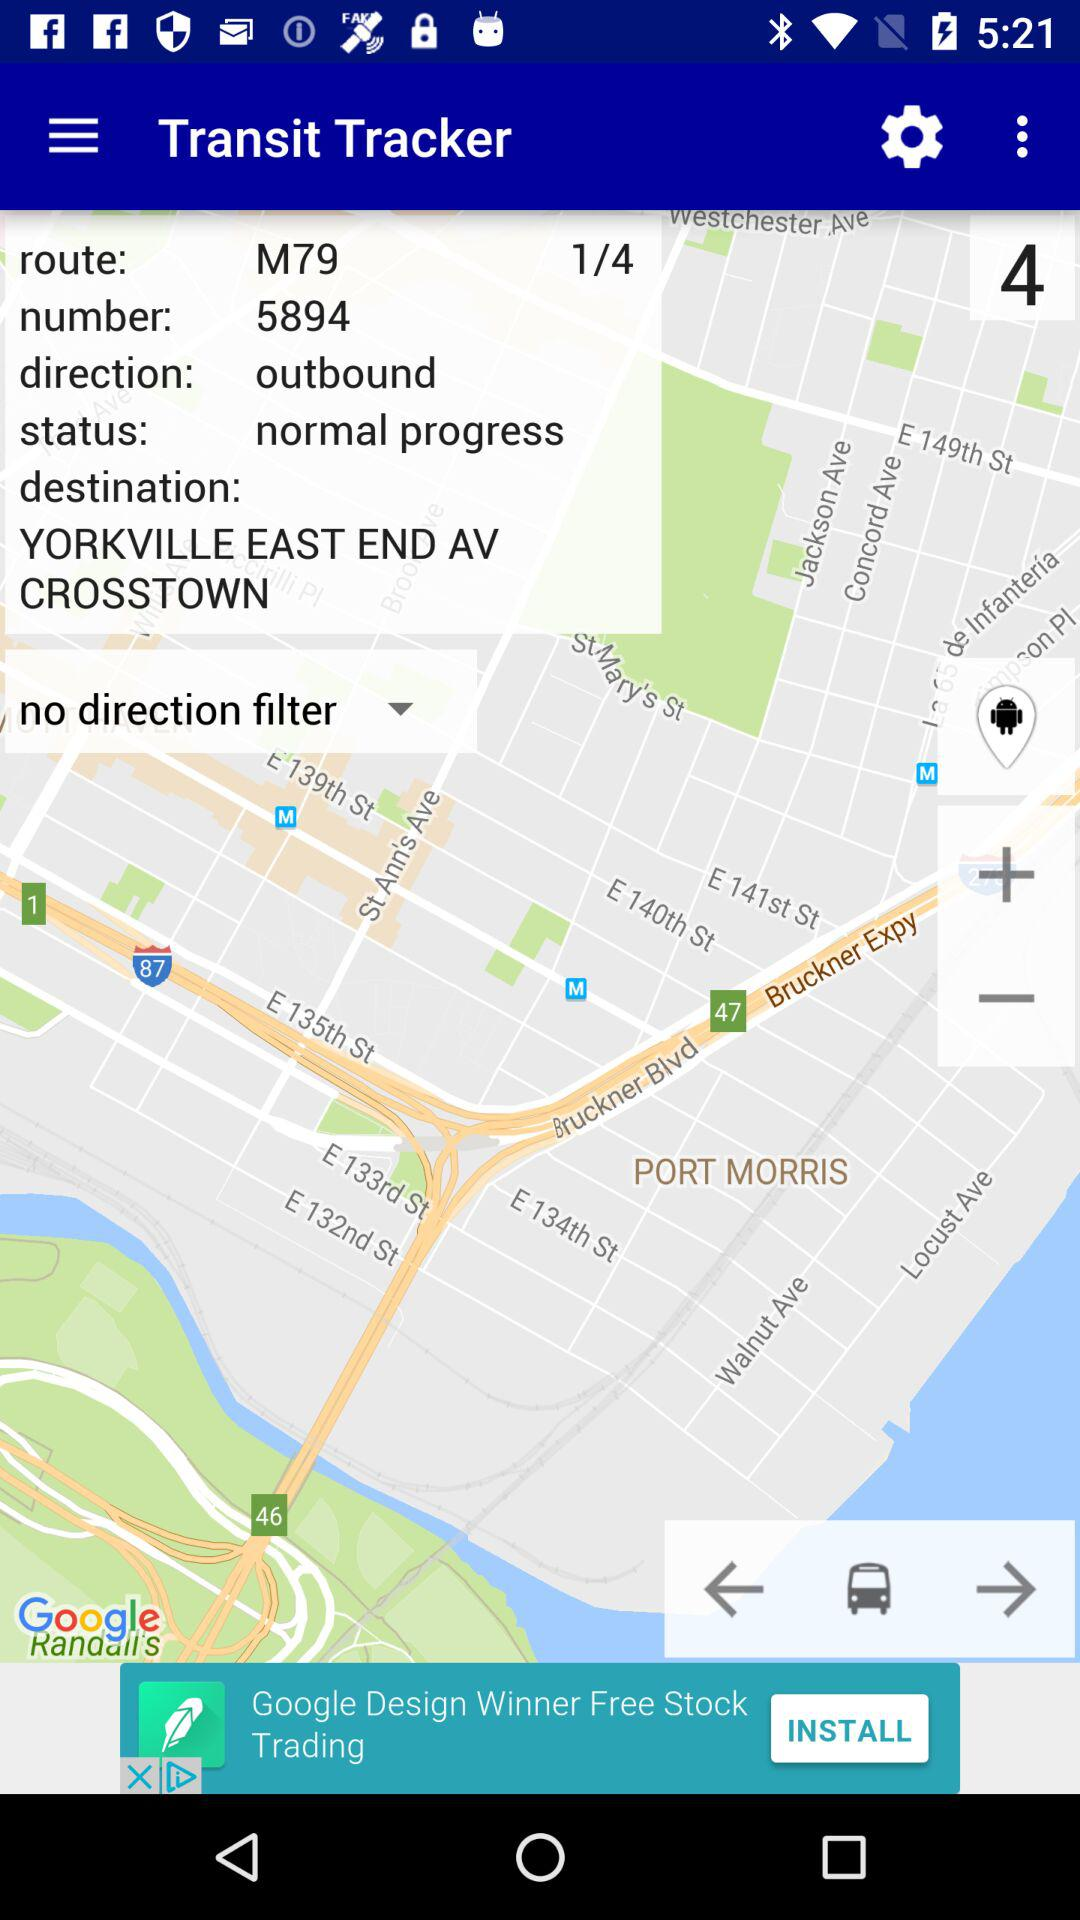What bus number is given? The given bus number is 5894. 